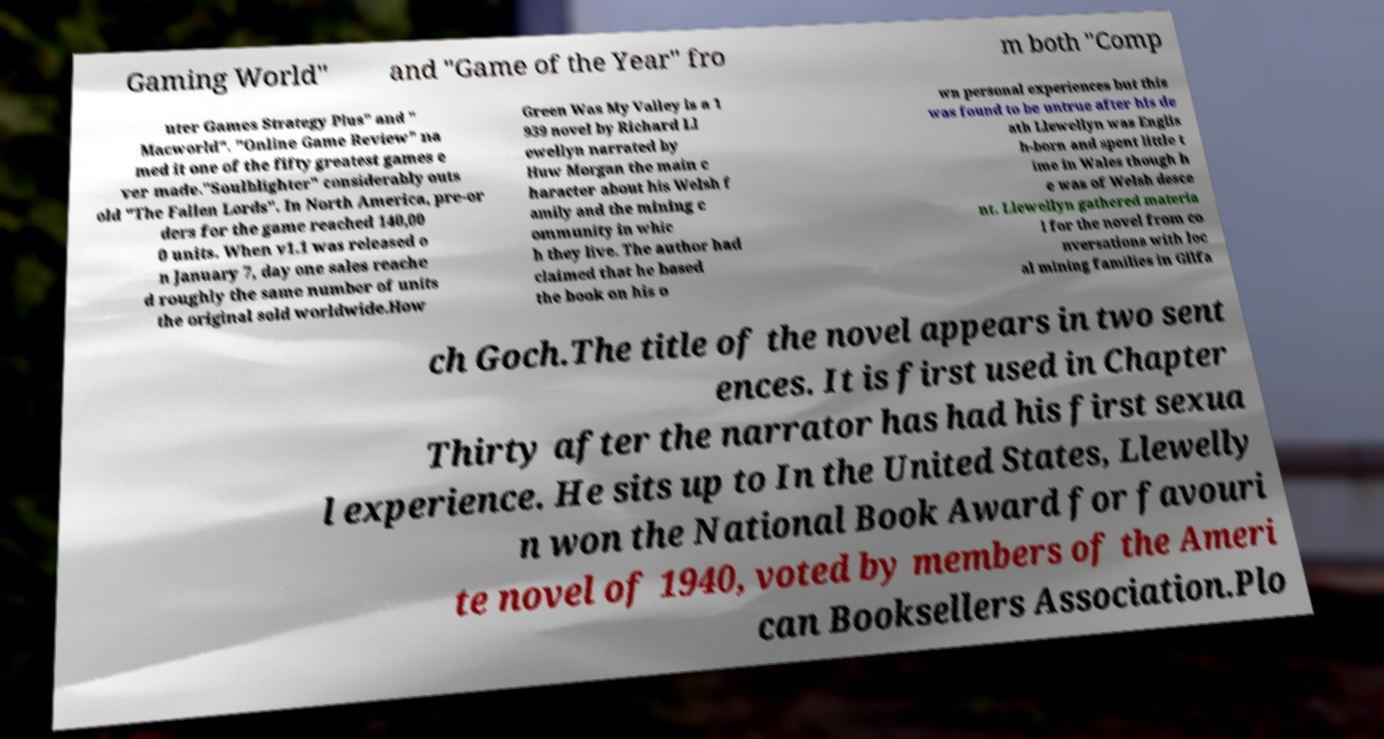Please identify and transcribe the text found in this image. Gaming World" and "Game of the Year" fro m both "Comp uter Games Strategy Plus" and " Macworld". "Online Game Review" na med it one of the fifty greatest games e ver made."Soulblighter" considerably outs old "The Fallen Lords". In North America, pre-or ders for the game reached 140,00 0 units. When v1.1 was released o n January 7, day one sales reache d roughly the same number of units the original sold worldwide.How Green Was My Valley is a 1 939 novel by Richard Ll ewellyn narrated by Huw Morgan the main c haracter about his Welsh f amily and the mining c ommunity in whic h they live. The author had claimed that he based the book on his o wn personal experiences but this was found to be untrue after his de ath Llewellyn was Englis h-born and spent little t ime in Wales though h e was of Welsh desce nt. Llewellyn gathered materia l for the novel from co nversations with loc al mining families in Gilfa ch Goch.The title of the novel appears in two sent ences. It is first used in Chapter Thirty after the narrator has had his first sexua l experience. He sits up to In the United States, Llewelly n won the National Book Award for favouri te novel of 1940, voted by members of the Ameri can Booksellers Association.Plo 